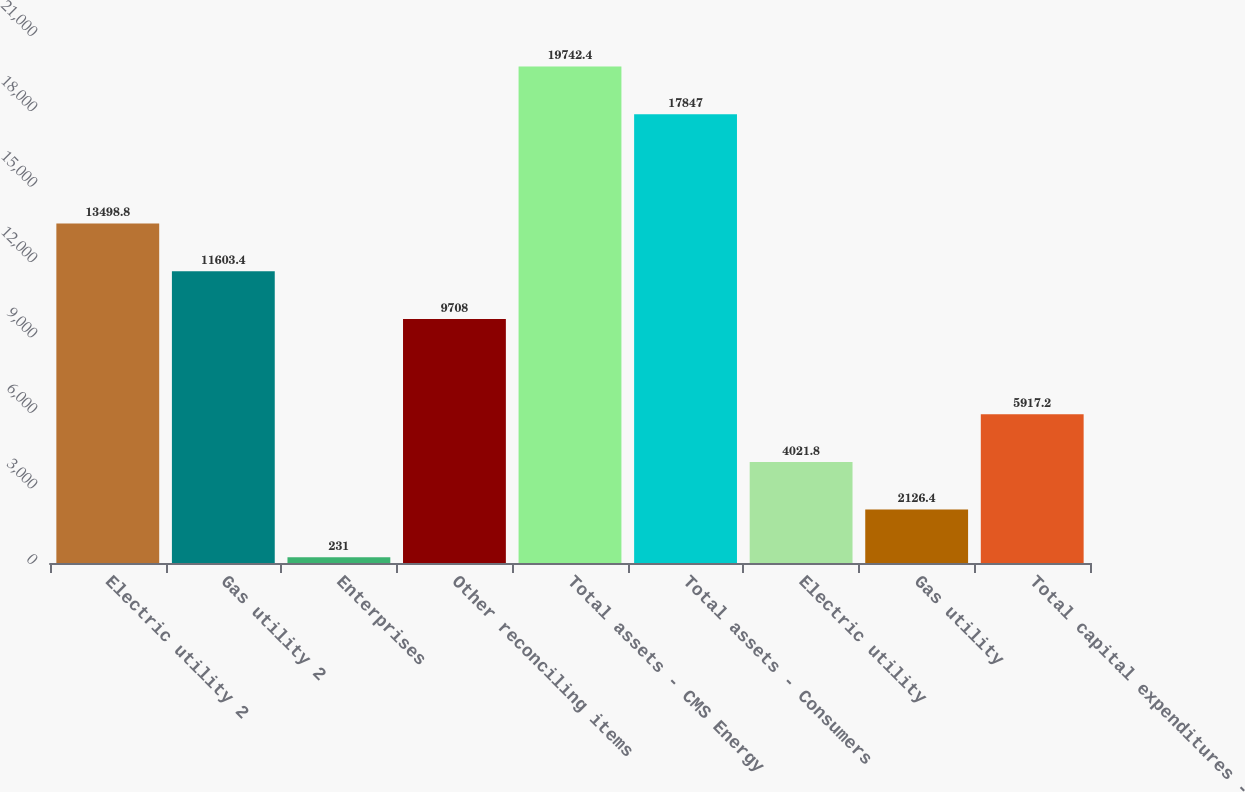Convert chart. <chart><loc_0><loc_0><loc_500><loc_500><bar_chart><fcel>Electric utility 2<fcel>Gas utility 2<fcel>Enterprises<fcel>Other reconciling items<fcel>Total assets - CMS Energy<fcel>Total assets - Consumers<fcel>Electric utility<fcel>Gas utility<fcel>Total capital expenditures -<nl><fcel>13498.8<fcel>11603.4<fcel>231<fcel>9708<fcel>19742.4<fcel>17847<fcel>4021.8<fcel>2126.4<fcel>5917.2<nl></chart> 